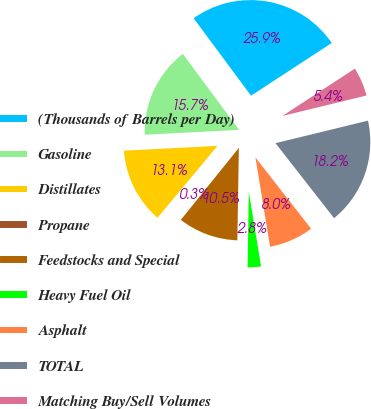<chart> <loc_0><loc_0><loc_500><loc_500><pie_chart><fcel>(Thousands of Barrels per Day)<fcel>Gasoline<fcel>Distillates<fcel>Propane<fcel>Feedstocks and Special<fcel>Heavy Fuel Oil<fcel>Asphalt<fcel>TOTAL<fcel>Matching Buy/Sell Volumes<nl><fcel>25.94%<fcel>15.67%<fcel>13.11%<fcel>0.27%<fcel>10.54%<fcel>2.84%<fcel>7.97%<fcel>18.24%<fcel>5.41%<nl></chart> 